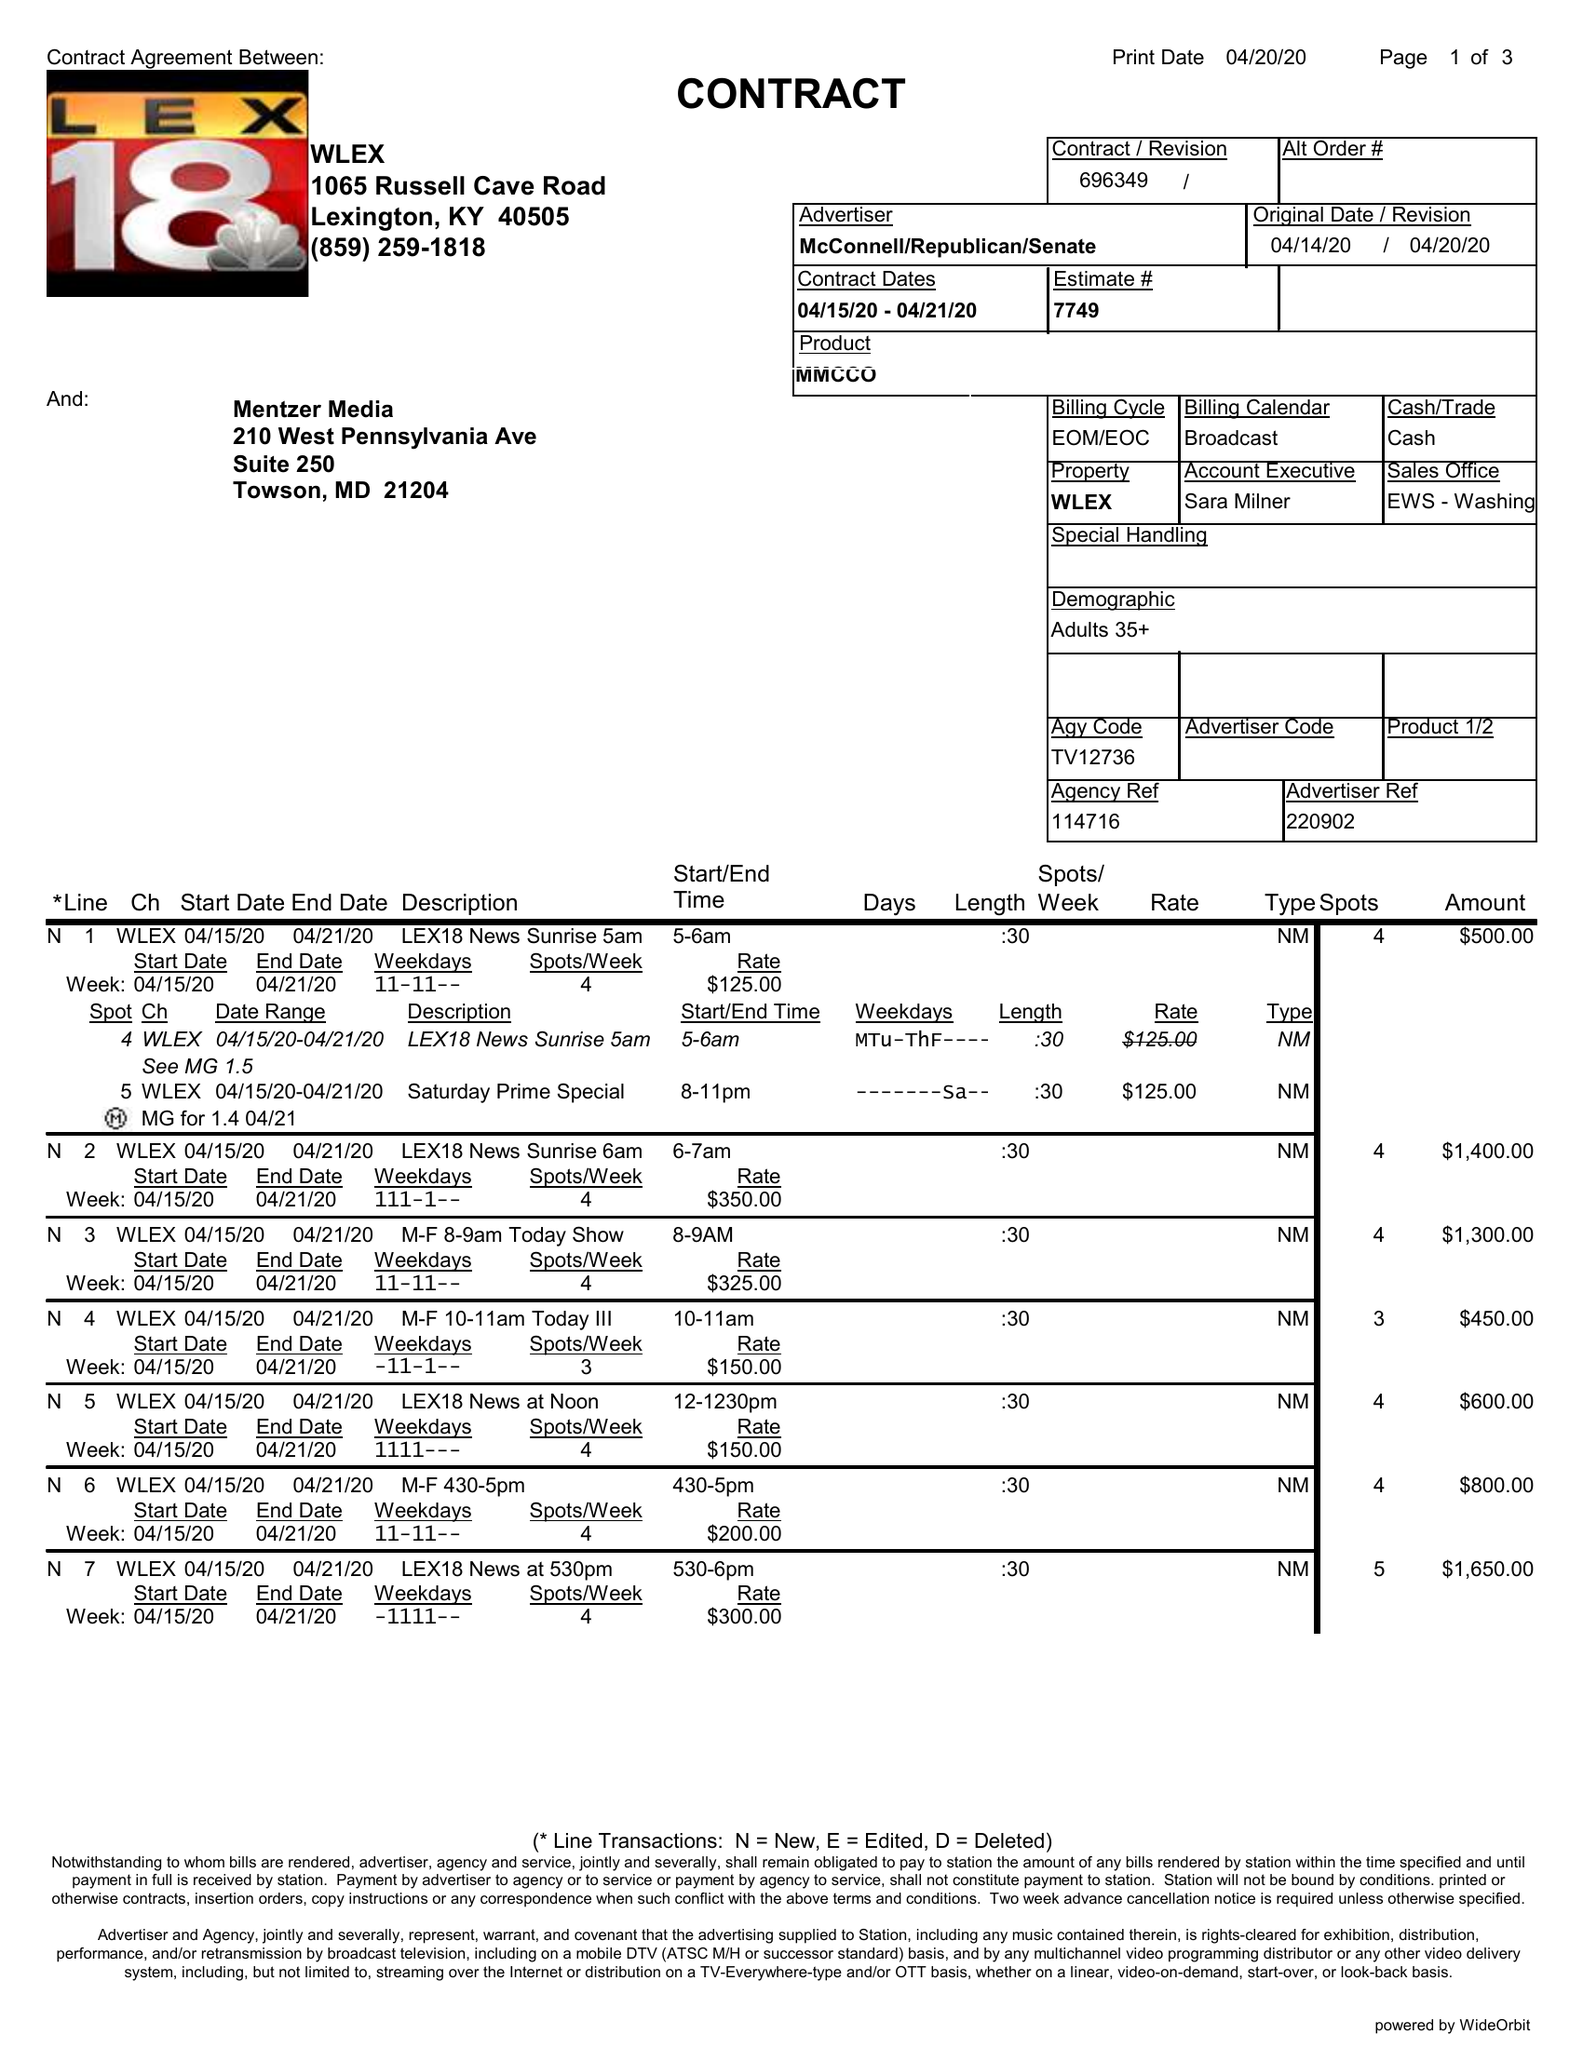What is the value for the advertiser?
Answer the question using a single word or phrase. MCCONNELL/REPUBLICAN/SENATE 